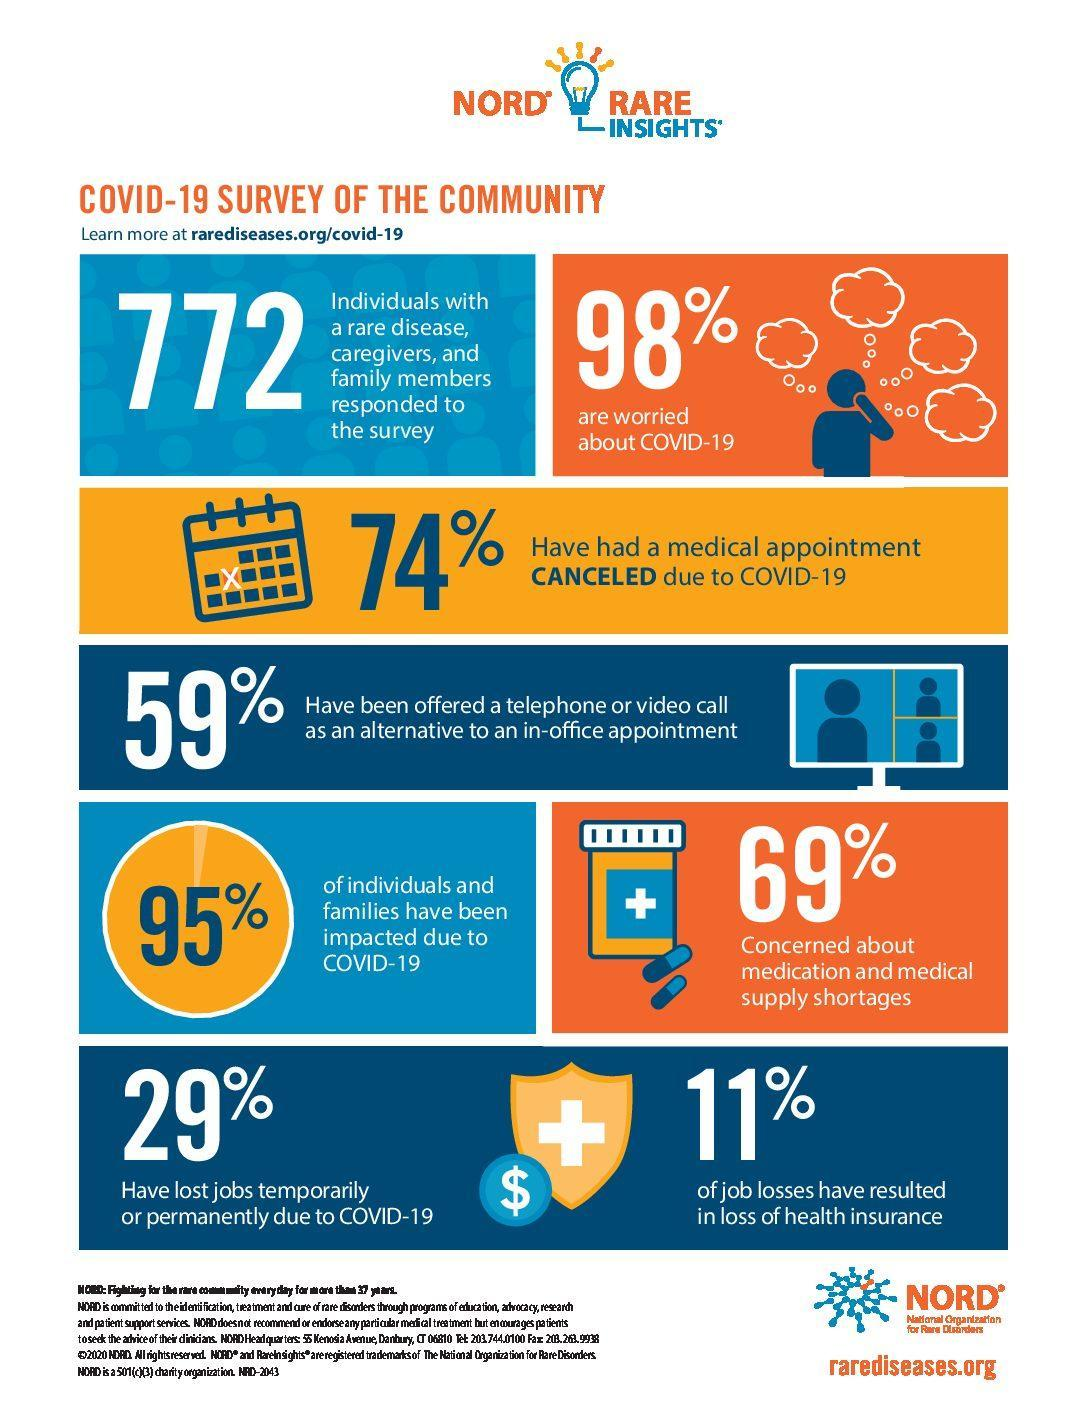What percentage of individuals and families have not been affected due to Covid -19?
Answer the question with a short phrase. 5% What percentage of people have not been offered a telephone or video call as an alternative to an in-office appointment? 41% What percentage of people are not worried about Covid-19? 2% What percentage of people have had a medical appointment during Covid-19? 26% What percentage of people are not concerned about medication and medical supply shortages? 31% 